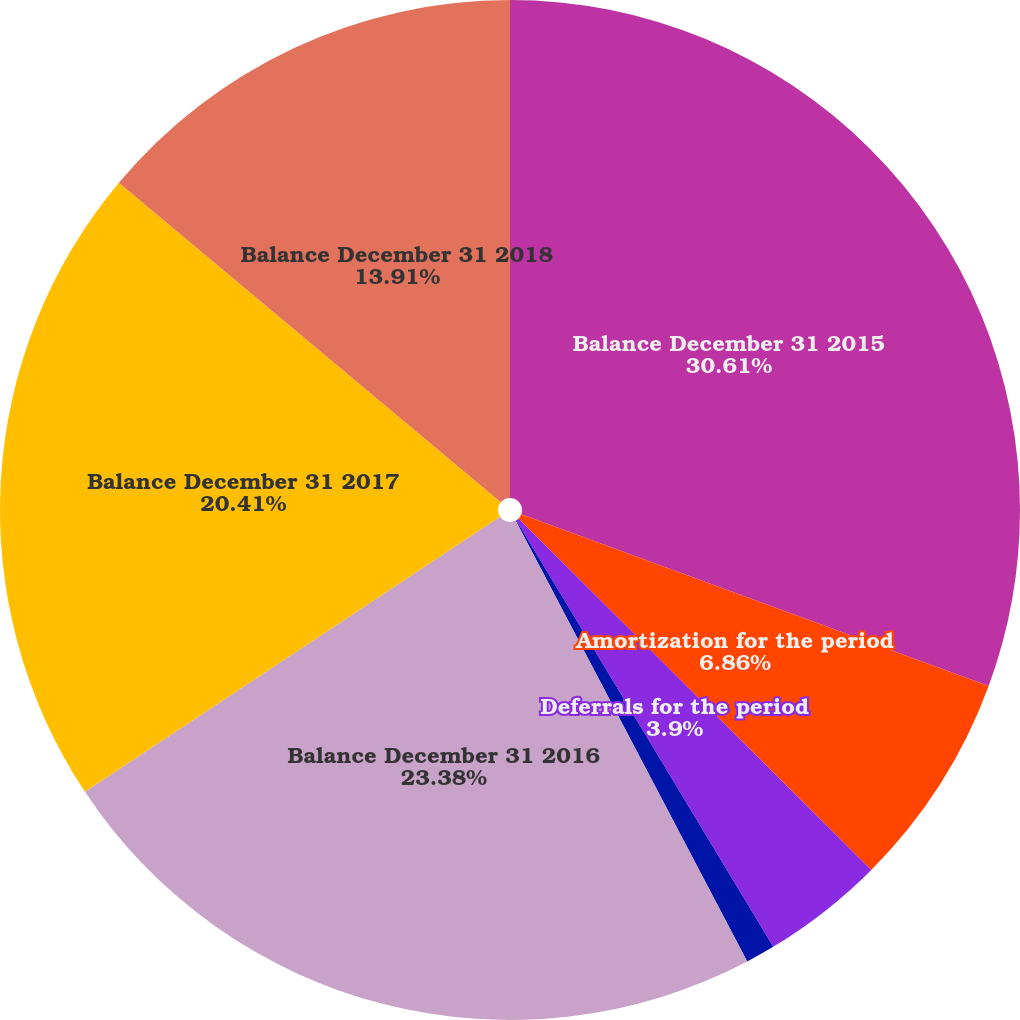Convert chart. <chart><loc_0><loc_0><loc_500><loc_500><pie_chart><fcel>Balance December 31 2015<fcel>Amortization for the period<fcel>Deferrals for the period<fcel>Impact of foreign currency<fcel>Balance December 31 2016<fcel>Balance December 31 2017<fcel>Balance December 31 2018<nl><fcel>30.61%<fcel>6.86%<fcel>3.9%<fcel>0.93%<fcel>23.38%<fcel>20.41%<fcel>13.91%<nl></chart> 